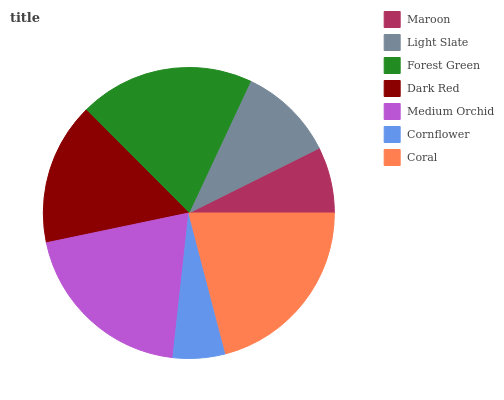Is Cornflower the minimum?
Answer yes or no. Yes. Is Coral the maximum?
Answer yes or no. Yes. Is Light Slate the minimum?
Answer yes or no. No. Is Light Slate the maximum?
Answer yes or no. No. Is Light Slate greater than Maroon?
Answer yes or no. Yes. Is Maroon less than Light Slate?
Answer yes or no. Yes. Is Maroon greater than Light Slate?
Answer yes or no. No. Is Light Slate less than Maroon?
Answer yes or no. No. Is Dark Red the high median?
Answer yes or no. Yes. Is Dark Red the low median?
Answer yes or no. Yes. Is Light Slate the high median?
Answer yes or no. No. Is Medium Orchid the low median?
Answer yes or no. No. 